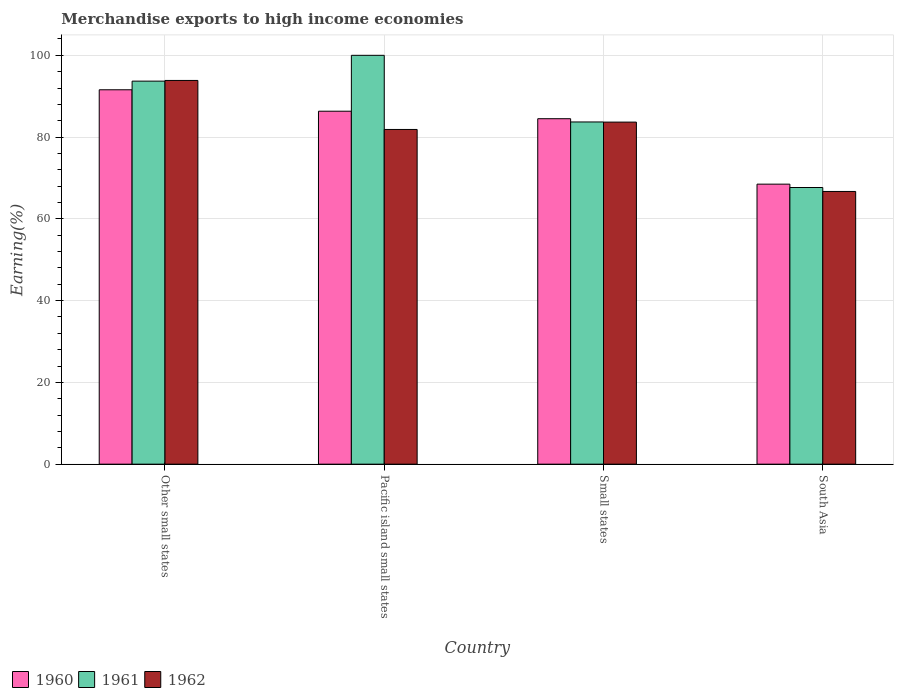How many different coloured bars are there?
Provide a short and direct response. 3. Are the number of bars per tick equal to the number of legend labels?
Keep it short and to the point. Yes. What is the label of the 3rd group of bars from the left?
Ensure brevity in your answer.  Small states. In how many cases, is the number of bars for a given country not equal to the number of legend labels?
Provide a succinct answer. 0. What is the percentage of amount earned from merchandise exports in 1962 in Pacific island small states?
Ensure brevity in your answer.  81.86. Across all countries, what is the maximum percentage of amount earned from merchandise exports in 1962?
Make the answer very short. 93.86. Across all countries, what is the minimum percentage of amount earned from merchandise exports in 1960?
Offer a terse response. 68.49. In which country was the percentage of amount earned from merchandise exports in 1960 maximum?
Provide a short and direct response. Other small states. In which country was the percentage of amount earned from merchandise exports in 1961 minimum?
Give a very brief answer. South Asia. What is the total percentage of amount earned from merchandise exports in 1960 in the graph?
Your answer should be very brief. 330.88. What is the difference between the percentage of amount earned from merchandise exports in 1960 in Other small states and that in Small states?
Provide a succinct answer. 7.08. What is the difference between the percentage of amount earned from merchandise exports in 1960 in Small states and the percentage of amount earned from merchandise exports in 1962 in Other small states?
Your answer should be very brief. -9.36. What is the average percentage of amount earned from merchandise exports in 1960 per country?
Give a very brief answer. 82.72. What is the difference between the percentage of amount earned from merchandise exports of/in 1962 and percentage of amount earned from merchandise exports of/in 1961 in Pacific island small states?
Keep it short and to the point. -18.14. In how many countries, is the percentage of amount earned from merchandise exports in 1960 greater than 76 %?
Offer a terse response. 3. What is the ratio of the percentage of amount earned from merchandise exports in 1962 in Other small states to that in South Asia?
Ensure brevity in your answer.  1.41. Is the percentage of amount earned from merchandise exports in 1961 in Pacific island small states less than that in Small states?
Offer a terse response. No. What is the difference between the highest and the second highest percentage of amount earned from merchandise exports in 1961?
Offer a very short reply. -16.3. What is the difference between the highest and the lowest percentage of amount earned from merchandise exports in 1961?
Ensure brevity in your answer.  32.33. Is the sum of the percentage of amount earned from merchandise exports in 1961 in Other small states and Small states greater than the maximum percentage of amount earned from merchandise exports in 1960 across all countries?
Make the answer very short. Yes. What does the 3rd bar from the left in South Asia represents?
Provide a short and direct response. 1962. What does the 2nd bar from the right in Other small states represents?
Keep it short and to the point. 1961. Are all the bars in the graph horizontal?
Your response must be concise. No. Does the graph contain any zero values?
Provide a short and direct response. No. Does the graph contain grids?
Provide a succinct answer. Yes. How many legend labels are there?
Keep it short and to the point. 3. What is the title of the graph?
Ensure brevity in your answer.  Merchandise exports to high income economies. Does "1982" appear as one of the legend labels in the graph?
Make the answer very short. No. What is the label or title of the Y-axis?
Give a very brief answer. Earning(%). What is the Earning(%) of 1960 in Other small states?
Your response must be concise. 91.57. What is the Earning(%) in 1961 in Other small states?
Keep it short and to the point. 93.69. What is the Earning(%) of 1962 in Other small states?
Offer a very short reply. 93.86. What is the Earning(%) in 1960 in Pacific island small states?
Provide a succinct answer. 86.33. What is the Earning(%) in 1962 in Pacific island small states?
Your answer should be compact. 81.86. What is the Earning(%) of 1960 in Small states?
Your answer should be very brief. 84.49. What is the Earning(%) of 1961 in Small states?
Your response must be concise. 83.7. What is the Earning(%) in 1962 in Small states?
Offer a very short reply. 83.67. What is the Earning(%) of 1960 in South Asia?
Your answer should be compact. 68.49. What is the Earning(%) of 1961 in South Asia?
Your answer should be very brief. 67.67. What is the Earning(%) in 1962 in South Asia?
Your response must be concise. 66.7. Across all countries, what is the maximum Earning(%) in 1960?
Offer a terse response. 91.57. Across all countries, what is the maximum Earning(%) of 1961?
Your answer should be very brief. 100. Across all countries, what is the maximum Earning(%) of 1962?
Your response must be concise. 93.86. Across all countries, what is the minimum Earning(%) in 1960?
Your response must be concise. 68.49. Across all countries, what is the minimum Earning(%) in 1961?
Make the answer very short. 67.67. Across all countries, what is the minimum Earning(%) in 1962?
Give a very brief answer. 66.7. What is the total Earning(%) of 1960 in the graph?
Your answer should be very brief. 330.88. What is the total Earning(%) in 1961 in the graph?
Offer a very short reply. 345.05. What is the total Earning(%) in 1962 in the graph?
Offer a very short reply. 326.09. What is the difference between the Earning(%) of 1960 in Other small states and that in Pacific island small states?
Offer a terse response. 5.24. What is the difference between the Earning(%) in 1961 in Other small states and that in Pacific island small states?
Make the answer very short. -6.31. What is the difference between the Earning(%) in 1962 in Other small states and that in Pacific island small states?
Offer a terse response. 11.99. What is the difference between the Earning(%) of 1960 in Other small states and that in Small states?
Ensure brevity in your answer.  7.08. What is the difference between the Earning(%) of 1961 in Other small states and that in Small states?
Provide a short and direct response. 9.99. What is the difference between the Earning(%) in 1962 in Other small states and that in Small states?
Your response must be concise. 10.19. What is the difference between the Earning(%) of 1960 in Other small states and that in South Asia?
Make the answer very short. 23.08. What is the difference between the Earning(%) in 1961 in Other small states and that in South Asia?
Provide a short and direct response. 26.02. What is the difference between the Earning(%) in 1962 in Other small states and that in South Asia?
Your answer should be very brief. 27.16. What is the difference between the Earning(%) in 1960 in Pacific island small states and that in Small states?
Your answer should be compact. 1.84. What is the difference between the Earning(%) in 1961 in Pacific island small states and that in Small states?
Ensure brevity in your answer.  16.3. What is the difference between the Earning(%) of 1962 in Pacific island small states and that in Small states?
Provide a short and direct response. -1.8. What is the difference between the Earning(%) of 1960 in Pacific island small states and that in South Asia?
Keep it short and to the point. 17.84. What is the difference between the Earning(%) in 1961 in Pacific island small states and that in South Asia?
Provide a short and direct response. 32.33. What is the difference between the Earning(%) of 1962 in Pacific island small states and that in South Asia?
Keep it short and to the point. 15.16. What is the difference between the Earning(%) in 1960 in Small states and that in South Asia?
Offer a very short reply. 16. What is the difference between the Earning(%) in 1961 in Small states and that in South Asia?
Ensure brevity in your answer.  16.03. What is the difference between the Earning(%) of 1962 in Small states and that in South Asia?
Keep it short and to the point. 16.97. What is the difference between the Earning(%) of 1960 in Other small states and the Earning(%) of 1961 in Pacific island small states?
Provide a short and direct response. -8.43. What is the difference between the Earning(%) of 1960 in Other small states and the Earning(%) of 1962 in Pacific island small states?
Ensure brevity in your answer.  9.71. What is the difference between the Earning(%) in 1961 in Other small states and the Earning(%) in 1962 in Pacific island small states?
Keep it short and to the point. 11.82. What is the difference between the Earning(%) of 1960 in Other small states and the Earning(%) of 1961 in Small states?
Make the answer very short. 7.87. What is the difference between the Earning(%) of 1960 in Other small states and the Earning(%) of 1962 in Small states?
Give a very brief answer. 7.9. What is the difference between the Earning(%) in 1961 in Other small states and the Earning(%) in 1962 in Small states?
Offer a very short reply. 10.02. What is the difference between the Earning(%) in 1960 in Other small states and the Earning(%) in 1961 in South Asia?
Offer a terse response. 23.9. What is the difference between the Earning(%) of 1960 in Other small states and the Earning(%) of 1962 in South Asia?
Ensure brevity in your answer.  24.87. What is the difference between the Earning(%) in 1961 in Other small states and the Earning(%) in 1962 in South Asia?
Offer a very short reply. 26.99. What is the difference between the Earning(%) in 1960 in Pacific island small states and the Earning(%) in 1961 in Small states?
Offer a terse response. 2.63. What is the difference between the Earning(%) of 1960 in Pacific island small states and the Earning(%) of 1962 in Small states?
Your answer should be very brief. 2.66. What is the difference between the Earning(%) in 1961 in Pacific island small states and the Earning(%) in 1962 in Small states?
Keep it short and to the point. 16.33. What is the difference between the Earning(%) of 1960 in Pacific island small states and the Earning(%) of 1961 in South Asia?
Make the answer very short. 18.66. What is the difference between the Earning(%) in 1960 in Pacific island small states and the Earning(%) in 1962 in South Asia?
Give a very brief answer. 19.63. What is the difference between the Earning(%) in 1961 in Pacific island small states and the Earning(%) in 1962 in South Asia?
Keep it short and to the point. 33.3. What is the difference between the Earning(%) in 1960 in Small states and the Earning(%) in 1961 in South Asia?
Your answer should be compact. 16.82. What is the difference between the Earning(%) of 1960 in Small states and the Earning(%) of 1962 in South Asia?
Ensure brevity in your answer.  17.79. What is the difference between the Earning(%) in 1961 in Small states and the Earning(%) in 1962 in South Asia?
Your answer should be very brief. 17. What is the average Earning(%) in 1960 per country?
Make the answer very short. 82.72. What is the average Earning(%) in 1961 per country?
Provide a succinct answer. 86.26. What is the average Earning(%) in 1962 per country?
Offer a very short reply. 81.52. What is the difference between the Earning(%) of 1960 and Earning(%) of 1961 in Other small states?
Offer a terse response. -2.11. What is the difference between the Earning(%) in 1960 and Earning(%) in 1962 in Other small states?
Give a very brief answer. -2.28. What is the difference between the Earning(%) in 1961 and Earning(%) in 1962 in Other small states?
Make the answer very short. -0.17. What is the difference between the Earning(%) of 1960 and Earning(%) of 1961 in Pacific island small states?
Offer a very short reply. -13.67. What is the difference between the Earning(%) of 1960 and Earning(%) of 1962 in Pacific island small states?
Make the answer very short. 4.47. What is the difference between the Earning(%) of 1961 and Earning(%) of 1962 in Pacific island small states?
Ensure brevity in your answer.  18.14. What is the difference between the Earning(%) in 1960 and Earning(%) in 1961 in Small states?
Make the answer very short. 0.79. What is the difference between the Earning(%) of 1960 and Earning(%) of 1962 in Small states?
Your answer should be compact. 0.83. What is the difference between the Earning(%) in 1961 and Earning(%) in 1962 in Small states?
Give a very brief answer. 0.03. What is the difference between the Earning(%) of 1960 and Earning(%) of 1961 in South Asia?
Your answer should be compact. 0.82. What is the difference between the Earning(%) in 1960 and Earning(%) in 1962 in South Asia?
Your answer should be very brief. 1.79. What is the ratio of the Earning(%) in 1960 in Other small states to that in Pacific island small states?
Give a very brief answer. 1.06. What is the ratio of the Earning(%) of 1961 in Other small states to that in Pacific island small states?
Keep it short and to the point. 0.94. What is the ratio of the Earning(%) of 1962 in Other small states to that in Pacific island small states?
Ensure brevity in your answer.  1.15. What is the ratio of the Earning(%) in 1960 in Other small states to that in Small states?
Provide a short and direct response. 1.08. What is the ratio of the Earning(%) of 1961 in Other small states to that in Small states?
Provide a short and direct response. 1.12. What is the ratio of the Earning(%) in 1962 in Other small states to that in Small states?
Offer a terse response. 1.12. What is the ratio of the Earning(%) of 1960 in Other small states to that in South Asia?
Your response must be concise. 1.34. What is the ratio of the Earning(%) in 1961 in Other small states to that in South Asia?
Keep it short and to the point. 1.38. What is the ratio of the Earning(%) in 1962 in Other small states to that in South Asia?
Give a very brief answer. 1.41. What is the ratio of the Earning(%) in 1960 in Pacific island small states to that in Small states?
Provide a succinct answer. 1.02. What is the ratio of the Earning(%) in 1961 in Pacific island small states to that in Small states?
Your response must be concise. 1.19. What is the ratio of the Earning(%) in 1962 in Pacific island small states to that in Small states?
Give a very brief answer. 0.98. What is the ratio of the Earning(%) in 1960 in Pacific island small states to that in South Asia?
Provide a short and direct response. 1.26. What is the ratio of the Earning(%) in 1961 in Pacific island small states to that in South Asia?
Your answer should be very brief. 1.48. What is the ratio of the Earning(%) of 1962 in Pacific island small states to that in South Asia?
Your response must be concise. 1.23. What is the ratio of the Earning(%) in 1960 in Small states to that in South Asia?
Keep it short and to the point. 1.23. What is the ratio of the Earning(%) of 1961 in Small states to that in South Asia?
Provide a succinct answer. 1.24. What is the ratio of the Earning(%) of 1962 in Small states to that in South Asia?
Your answer should be very brief. 1.25. What is the difference between the highest and the second highest Earning(%) of 1960?
Your answer should be very brief. 5.24. What is the difference between the highest and the second highest Earning(%) in 1961?
Make the answer very short. 6.31. What is the difference between the highest and the second highest Earning(%) in 1962?
Give a very brief answer. 10.19. What is the difference between the highest and the lowest Earning(%) of 1960?
Keep it short and to the point. 23.08. What is the difference between the highest and the lowest Earning(%) in 1961?
Ensure brevity in your answer.  32.33. What is the difference between the highest and the lowest Earning(%) of 1962?
Provide a short and direct response. 27.16. 